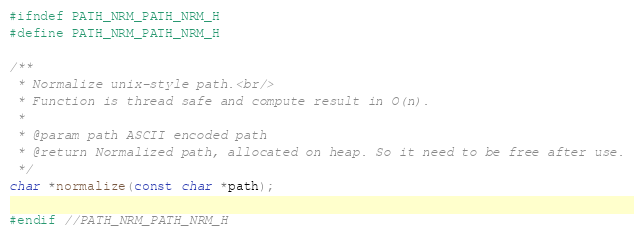Convert code to text. <code><loc_0><loc_0><loc_500><loc_500><_C_>#ifndef PATH_NRM_PATH_NRM_H
#define PATH_NRM_PATH_NRM_H

/**
 * Normalize unix-style path.<br/>
 * Function is thread safe and compute result in O(n).
 *
 * @param path ASCII encoded path
 * @return Normalized path, allocated on heap. So it need to be free after use.
 */
char *normalize(const char *path);

#endif //PATH_NRM_PATH_NRM_H
</code> 